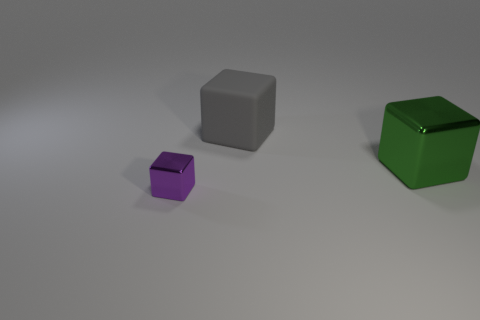What can the arrangement of these cubes tell us about the spatial relations in the image? The arrangement demonstrates relative size and distance. The green cube appears to be the largest and closest to the viewpoint. The gray cube is in the middle in both size and distance, while the purple cube is the smallest and appears furthest away. This setup might be used to showcase perspective or to create a composition that guides the viewer's eye from one object to another in a deliberate order. Is there anything noteworthy about the lighting in the image? The lighting in the image seems ambient with soft shadows, indicating a diffuse light source. The absence of harsh shadows or high contrast suggests a controlled lighting environment, which is common in studio settings. This kind of lighting is typically used to minimize distracting elements and focus attention on the objects themselves. 